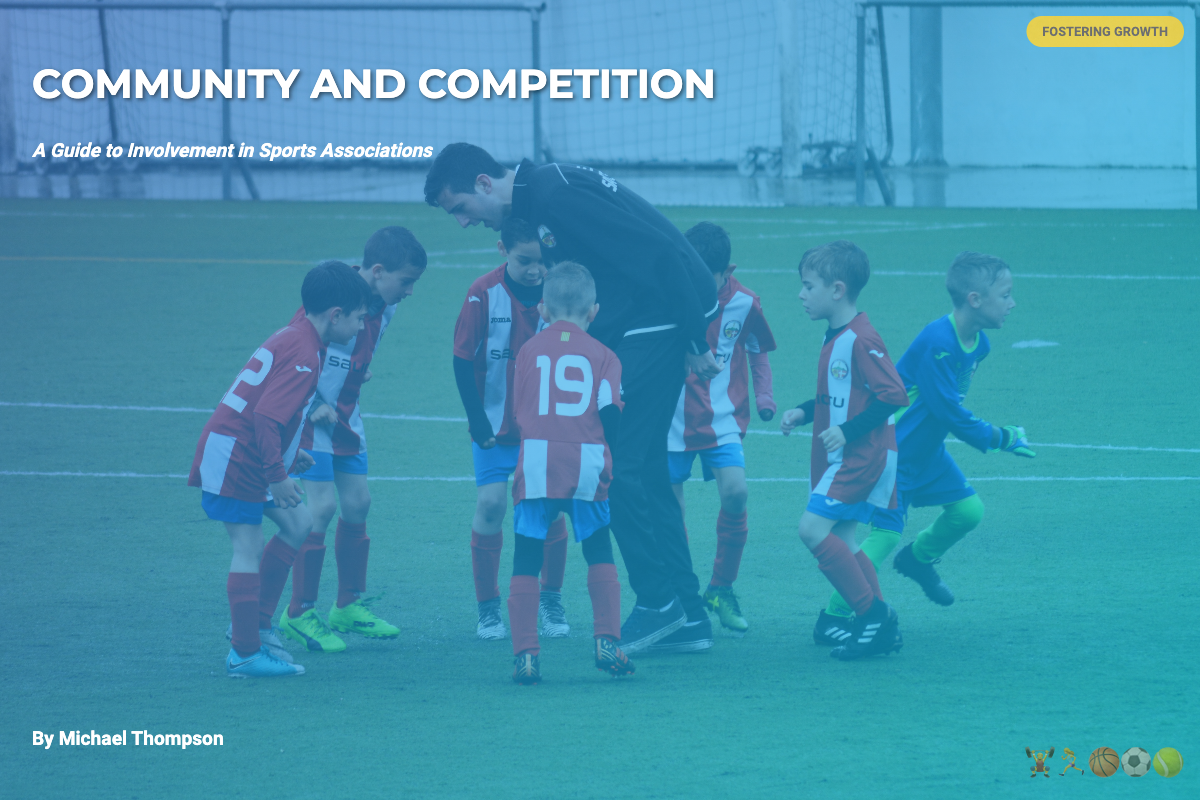What is the title of the book? The title is displayed prominently at the top of the cover in large letters.
Answer: Community and Competition Who is the author of the book? The author's name is listed at the bottom of the content area on the cover.
Answer: Michael Thompson What is the subtitle of the book? The subtitle appears under the title, providing more context about the book's content.
Answer: A Guide to Involvement in Sports Associations What is the color of the badge on the cover? The badge is located at the top right corner and is described by its distinct color.
Answer: Gold How many sports symbols are there? The symbols at the bottom right corner of the cover represent various sports and can be counted.
Answer: Five What does the badge say? The text inside the badge indicates a theme or purpose of the book, shown prominently in the corner.
Answer: Fostering Growth What is the background style of the cover? The background gradient color created a visually appealing design element for the cover.
Answer: Gradient Where are the sports symbols located? The specific position of the sports symbols is indicated within the layout of the book cover.
Answer: Bottom right corner 